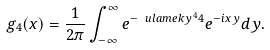Convert formula to latex. <formula><loc_0><loc_0><loc_500><loc_500>g _ { 4 } ( x ) = \frac { 1 } { 2 \pi } \int _ { - \infty } ^ { \infty } e ^ { - \ u l a m e k { y ^ { 4 } } { 4 } } e ^ { - i x y } d y .</formula> 